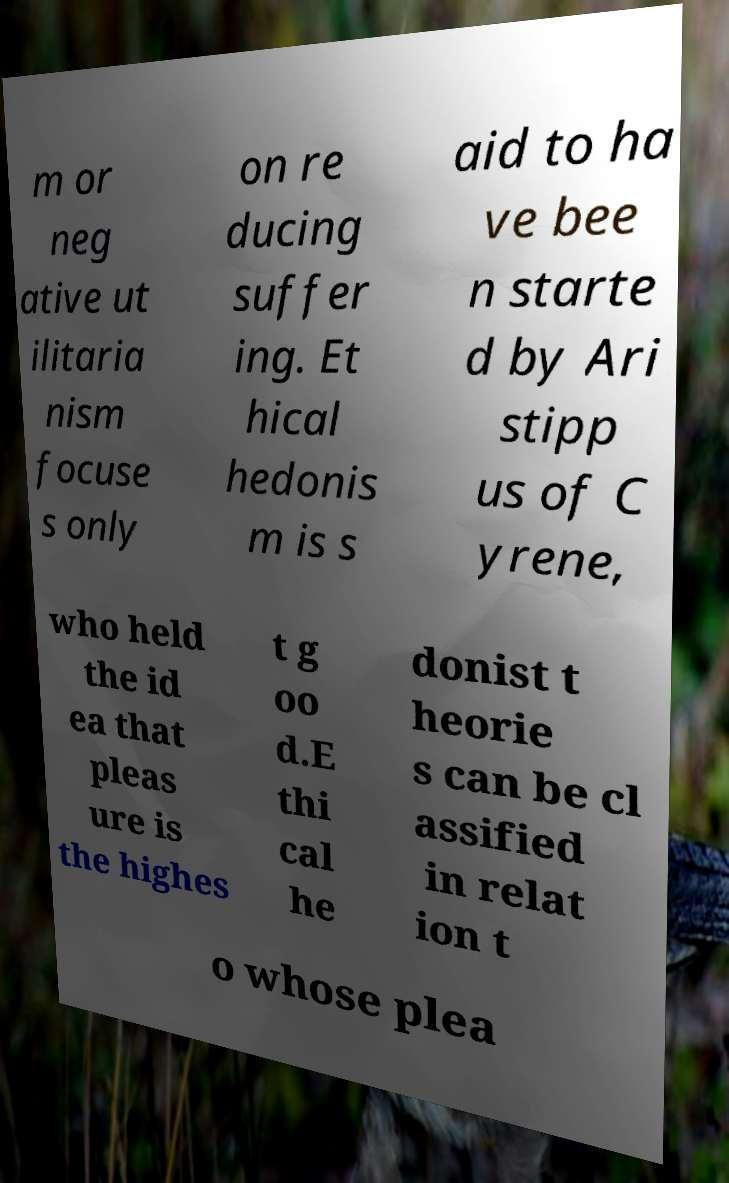What messages or text are displayed in this image? I need them in a readable, typed format. m or neg ative ut ilitaria nism focuse s only on re ducing suffer ing. Et hical hedonis m is s aid to ha ve bee n starte d by Ari stipp us of C yrene, who held the id ea that pleas ure is the highes t g oo d.E thi cal he donist t heorie s can be cl assified in relat ion t o whose plea 